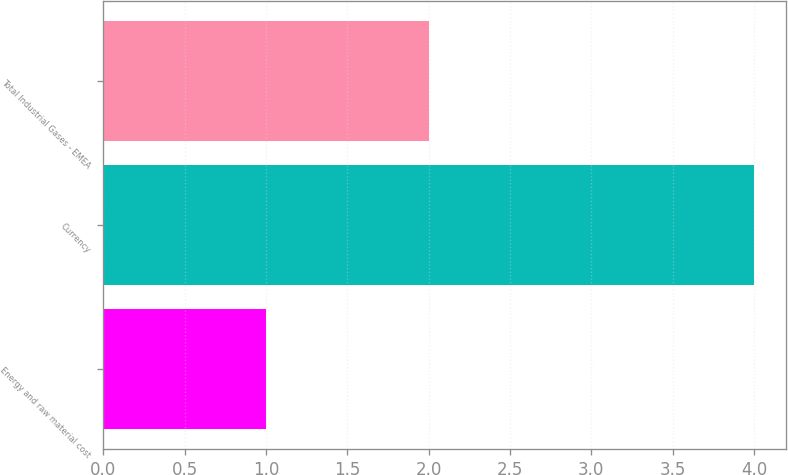Convert chart. <chart><loc_0><loc_0><loc_500><loc_500><bar_chart><fcel>Energy and raw material cost<fcel>Currency<fcel>Total Industrial Gases - EMEA<nl><fcel>1<fcel>4<fcel>2<nl></chart> 